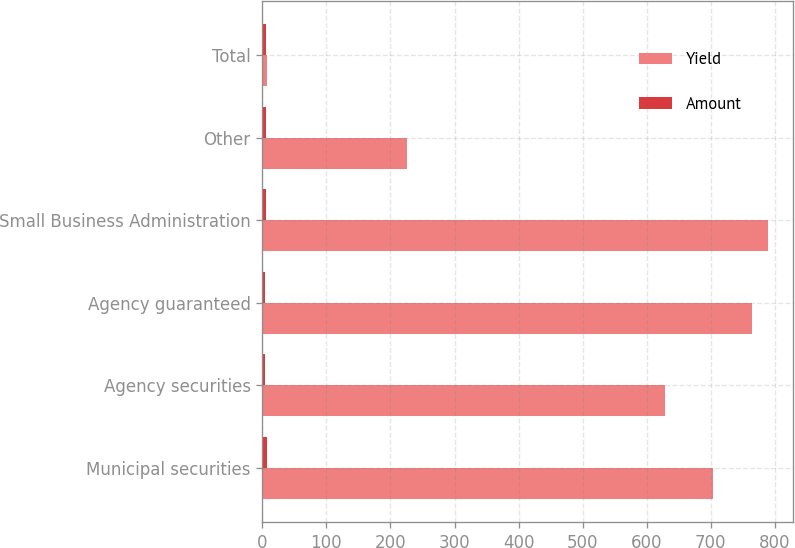Convert chart. <chart><loc_0><loc_0><loc_500><loc_500><stacked_bar_chart><ecel><fcel>Municipal securities<fcel>Agency securities<fcel>Agency guaranteed<fcel>Small Business Administration<fcel>Other<fcel>Total<nl><fcel>Yield<fcel>704<fcel>629<fcel>765<fcel>789<fcel>226<fcel>7.3<nl><fcel>Amount<fcel>7.3<fcel>4.7<fcel>4.8<fcel>5.3<fcel>5.9<fcel>5.7<nl></chart> 